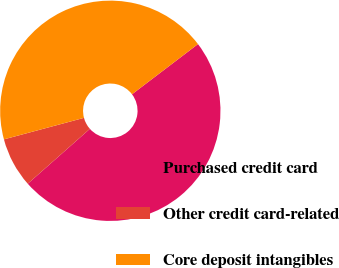<chart> <loc_0><loc_0><loc_500><loc_500><pie_chart><fcel>Purchased credit card<fcel>Other credit card-related<fcel>Core deposit intangibles<nl><fcel>48.83%<fcel>7.34%<fcel>43.83%<nl></chart> 